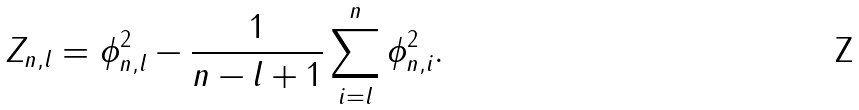<formula> <loc_0><loc_0><loc_500><loc_500>Z _ { n , l } = \phi _ { n , l } ^ { 2 } - \frac { 1 } { n - l + 1 } \sum _ { i = l } ^ { n } \phi _ { n , i } ^ { 2 } .</formula> 